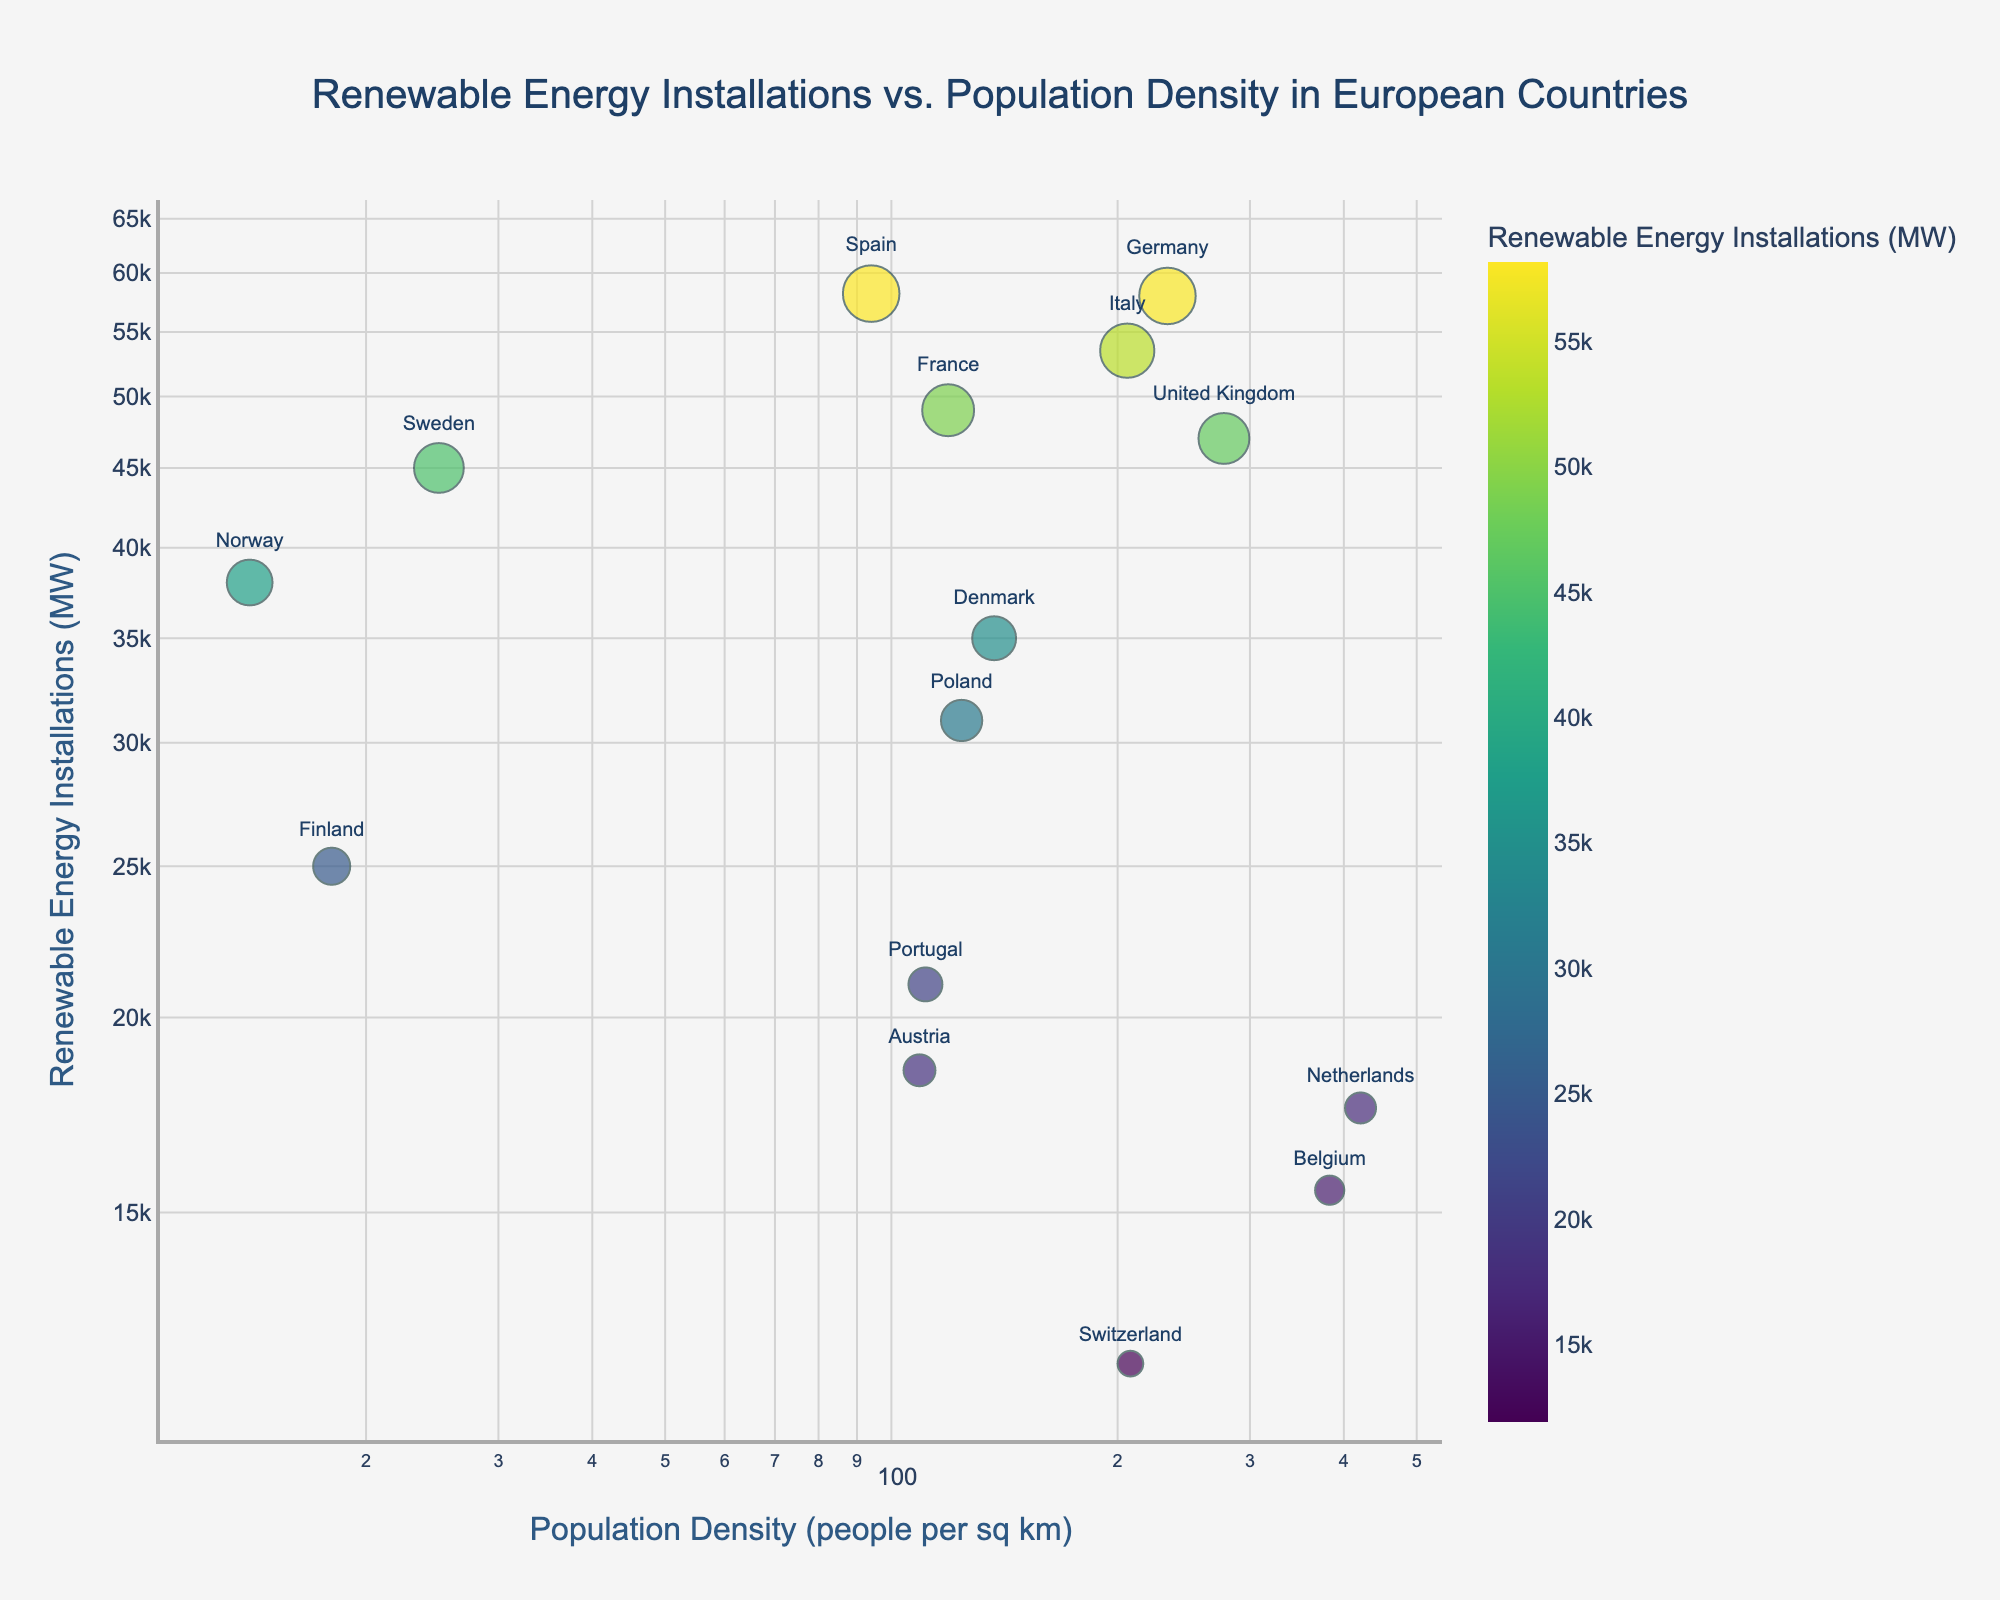What is the title of the figure? The title of the figure is the text at the top that briefly describes what the figure is about.
Answer: Renewable Energy Installations vs. Population Density in European Countries How many countries are represented in the plot? Count the number of data points in the scatter plot, with each point representing a country.
Answer: 15 Which country has the highest renewable energy installations? Look for the point with the highest y-coordinate and refer to the country label next to it.
Answer: Spain Which country has the lowest population density? Look for the point with the smallest x-coordinate and refer to the country label next to it.
Answer: Norway What is the population density of the UK? Identify the point labeled "United Kingdom" and read the x-coordinate value on the log scale axis.
Answer: 277 people per sq km Compare the renewable energy installations between Germany and France. Which country has more? Identify the points labeled "Germany" and "France," then compare their y-coordinate values. Germany has a y-coordinate of 58000 MW, and France has 49000 MW, so Germany has more.
Answer: Germany Which country has a population density closest to 100 people per sq km? Look for the point with an x-coordinate closest to the log-scaled value of 100 and check the country label.
Answer: Austria What is the median value of the renewable energy installations for all countries represented? List all the y-coordinate values (representing renewable energy installations), sort them, and find the middle value. The sorted list is 12000, 15500, 17500, 18500, 21000, 25000, 31000, 35000, 38000, 45000, 47000, 49000, 53500, 58000, 58200. The middle value (the 8th in a list of 15) is 35000 MW.
Answer: 35000 MW Do countries with higher population densities tend to have higher renewable energy installations? Look for a pattern in the scatter plot: check if points with higher x-coordinates (population densities) also tend to have higher y-coordinates (renewable energy installations). There is no clear pattern.
Answer: No Are there more countries with renewable energy installations above or below 40000 MW? Count the number of points above and below the y-coordinate value of 40000 on the log scale. Above: 8 countries (Germany, France, Spain, Italy, UK, Sweden, Finland, Norway). Below: 7 countries (Netherlands, Poland, Belgium, Portugal, Austria, Switzerland, Denmark).
Answer: Above 